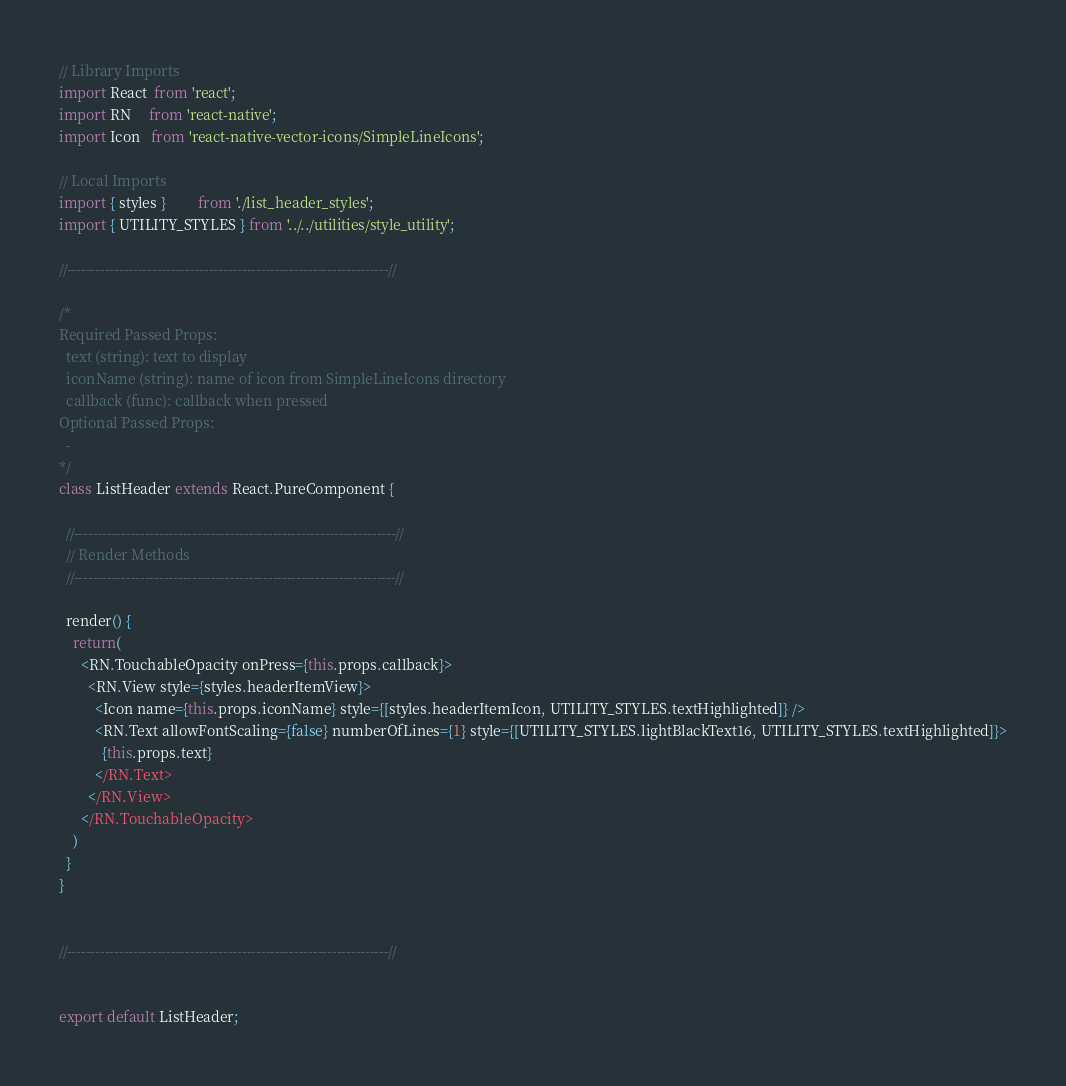Convert code to text. <code><loc_0><loc_0><loc_500><loc_500><_JavaScript_>// Library Imports
import React  from 'react';
import RN     from 'react-native';
import Icon   from 'react-native-vector-icons/SimpleLineIcons';

// Local Imports
import { styles }         from './list_header_styles';
import { UTILITY_STYLES } from '../../utilities/style_utility';

//--------------------------------------------------------------------//

/*
Required Passed Props:
  text (string): text to display
  iconName (string): name of icon from SimpleLineIcons directory
  callback (func): callback when pressed
Optional Passed Props:
  -
*/
class ListHeader extends React.PureComponent {

  //--------------------------------------------------------------------//
  // Render Methods
  //--------------------------------------------------------------------//

  render() {
    return(
      <RN.TouchableOpacity onPress={this.props.callback}>
        <RN.View style={styles.headerItemView}>
          <Icon name={this.props.iconName} style={[styles.headerItemIcon, UTILITY_STYLES.textHighlighted]} />
          <RN.Text allowFontScaling={false} numberOfLines={1} style={[UTILITY_STYLES.lightBlackText16, UTILITY_STYLES.textHighlighted]}>
            {this.props.text}
          </RN.Text>
        </RN.View>
      </RN.TouchableOpacity>
    )
  }
}


//--------------------------------------------------------------------//


export default ListHeader;
</code> 